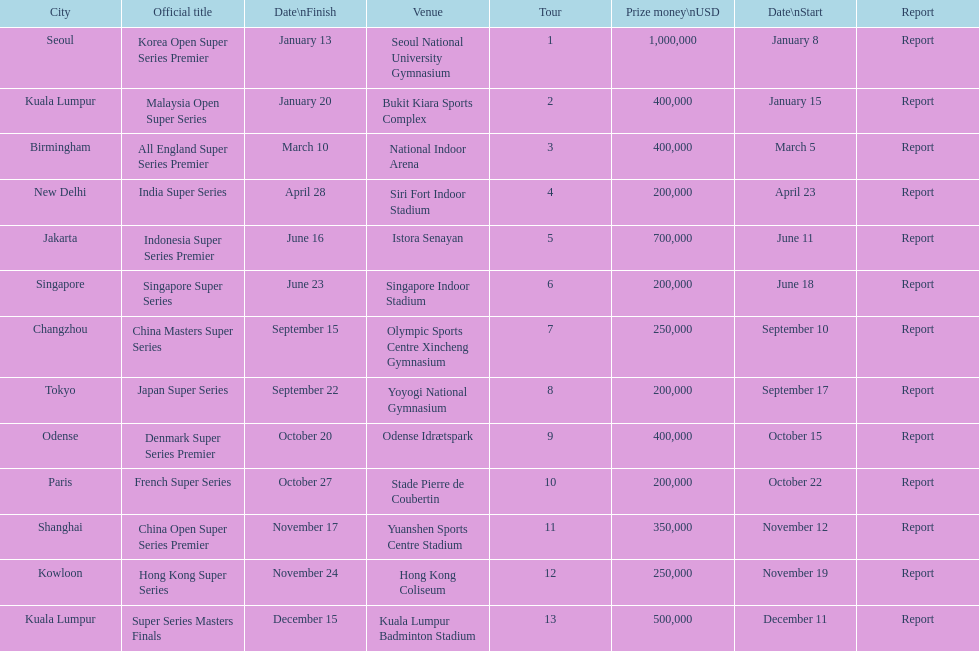How many days does the japan super series last? 5. 